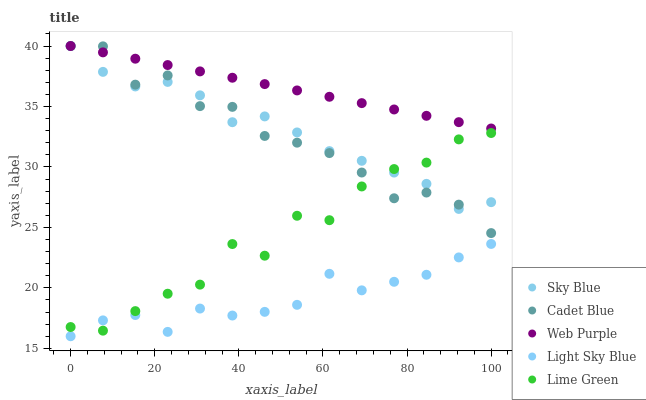Does Light Sky Blue have the minimum area under the curve?
Answer yes or no. Yes. Does Web Purple have the maximum area under the curve?
Answer yes or no. Yes. Does Cadet Blue have the minimum area under the curve?
Answer yes or no. No. Does Cadet Blue have the maximum area under the curve?
Answer yes or no. No. Is Web Purple the smoothest?
Answer yes or no. Yes. Is Lime Green the roughest?
Answer yes or no. Yes. Is Cadet Blue the smoothest?
Answer yes or no. No. Is Cadet Blue the roughest?
Answer yes or no. No. Does Light Sky Blue have the lowest value?
Answer yes or no. Yes. Does Cadet Blue have the lowest value?
Answer yes or no. No. Does Cadet Blue have the highest value?
Answer yes or no. Yes. Does Lime Green have the highest value?
Answer yes or no. No. Is Light Sky Blue less than Web Purple?
Answer yes or no. Yes. Is Web Purple greater than Lime Green?
Answer yes or no. Yes. Does Web Purple intersect Sky Blue?
Answer yes or no. Yes. Is Web Purple less than Sky Blue?
Answer yes or no. No. Is Web Purple greater than Sky Blue?
Answer yes or no. No. Does Light Sky Blue intersect Web Purple?
Answer yes or no. No. 